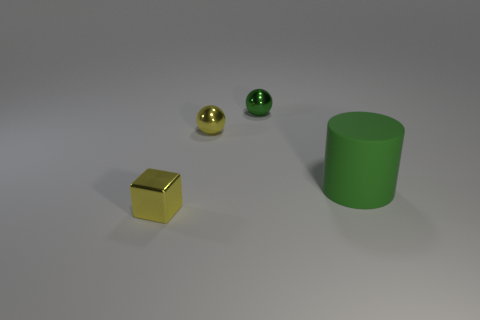What could be the purpose of these objects, and what setting might they be used in? The objects in the image seem to be simple geometric shapes likely used for illustrative, educational or design purposes. They could serve as teaching tools for lessons in geometry or physics, or as elements in a computer graphics demonstration. Their stark forms and differing materials make them ideal for such contexts where visual clarity and material contrast are key. 